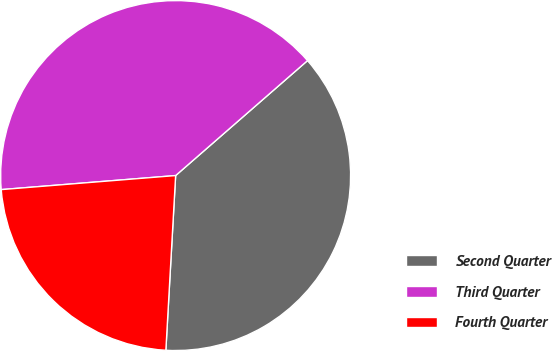<chart> <loc_0><loc_0><loc_500><loc_500><pie_chart><fcel>Second Quarter<fcel>Third Quarter<fcel>Fourth Quarter<nl><fcel>37.3%<fcel>39.87%<fcel>22.83%<nl></chart> 